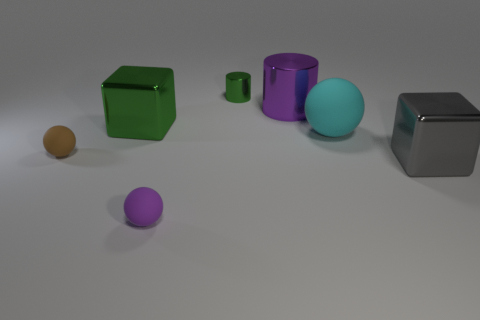Subtract all small brown balls. How many balls are left? 2 Add 1 large cyan objects. How many objects exist? 8 Subtract all spheres. How many objects are left? 4 Subtract all large metallic blocks. Subtract all large green shiny blocks. How many objects are left? 4 Add 2 small brown spheres. How many small brown spheres are left? 3 Add 6 big cyan spheres. How many big cyan spheres exist? 7 Subtract all gray blocks. How many blocks are left? 1 Subtract 1 green blocks. How many objects are left? 6 Subtract 3 balls. How many balls are left? 0 Subtract all yellow cylinders. Subtract all blue cubes. How many cylinders are left? 2 